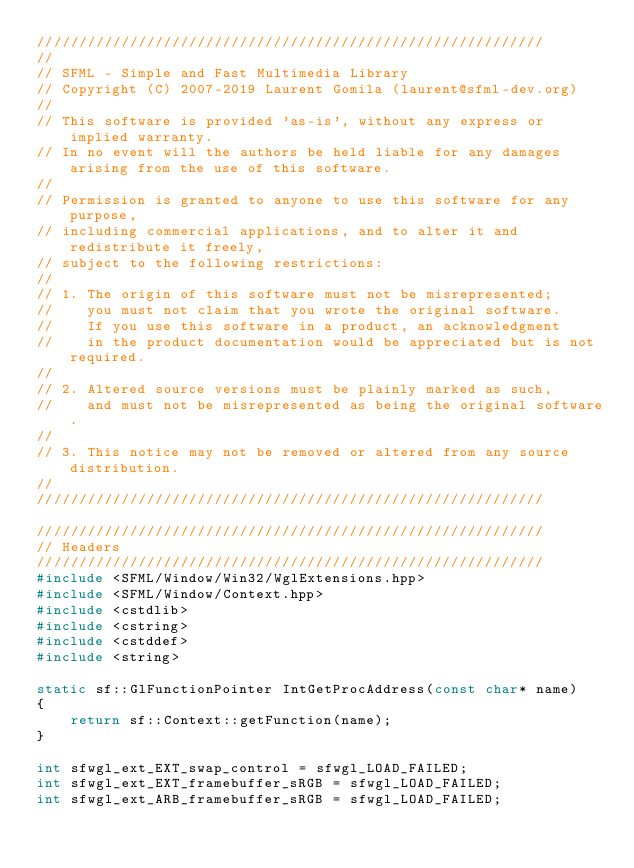Convert code to text. <code><loc_0><loc_0><loc_500><loc_500><_C++_>////////////////////////////////////////////////////////////
//
// SFML - Simple and Fast Multimedia Library
// Copyright (C) 2007-2019 Laurent Gomila (laurent@sfml-dev.org)
//
// This software is provided 'as-is', without any express or implied warranty.
// In no event will the authors be held liable for any damages arising from the use of this software.
//
// Permission is granted to anyone to use this software for any purpose,
// including commercial applications, and to alter it and redistribute it freely,
// subject to the following restrictions:
//
// 1. The origin of this software must not be misrepresented;
//    you must not claim that you wrote the original software.
//    If you use this software in a product, an acknowledgment
//    in the product documentation would be appreciated but is not required.
//
// 2. Altered source versions must be plainly marked as such,
//    and must not be misrepresented as being the original software.
//
// 3. This notice may not be removed or altered from any source distribution.
//
////////////////////////////////////////////////////////////

////////////////////////////////////////////////////////////
// Headers
////////////////////////////////////////////////////////////
#include <SFML/Window/Win32/WglExtensions.hpp>
#include <SFML/Window/Context.hpp>
#include <cstdlib>
#include <cstring>
#include <cstddef>
#include <string>

static sf::GlFunctionPointer IntGetProcAddress(const char* name)
{
    return sf::Context::getFunction(name);
}

int sfwgl_ext_EXT_swap_control = sfwgl_LOAD_FAILED;
int sfwgl_ext_EXT_framebuffer_sRGB = sfwgl_LOAD_FAILED;
int sfwgl_ext_ARB_framebuffer_sRGB = sfwgl_LOAD_FAILED;</code> 